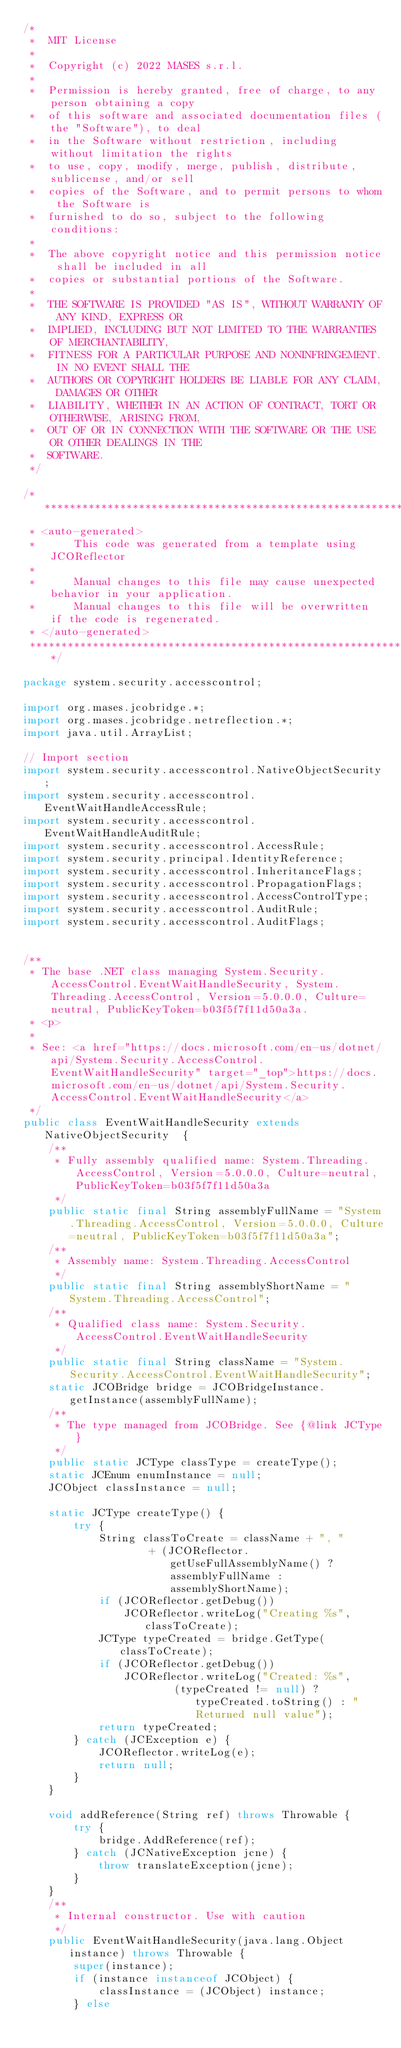<code> <loc_0><loc_0><loc_500><loc_500><_Java_>/*
 *  MIT License
 *
 *  Copyright (c) 2022 MASES s.r.l.
 *
 *  Permission is hereby granted, free of charge, to any person obtaining a copy
 *  of this software and associated documentation files (the "Software"), to deal
 *  in the Software without restriction, including without limitation the rights
 *  to use, copy, modify, merge, publish, distribute, sublicense, and/or sell
 *  copies of the Software, and to permit persons to whom the Software is
 *  furnished to do so, subject to the following conditions:
 *
 *  The above copyright notice and this permission notice shall be included in all
 *  copies or substantial portions of the Software.
 *
 *  THE SOFTWARE IS PROVIDED "AS IS", WITHOUT WARRANTY OF ANY KIND, EXPRESS OR
 *  IMPLIED, INCLUDING BUT NOT LIMITED TO THE WARRANTIES OF MERCHANTABILITY,
 *  FITNESS FOR A PARTICULAR PURPOSE AND NONINFRINGEMENT. IN NO EVENT SHALL THE
 *  AUTHORS OR COPYRIGHT HOLDERS BE LIABLE FOR ANY CLAIM, DAMAGES OR OTHER
 *  LIABILITY, WHETHER IN AN ACTION OF CONTRACT, TORT OR OTHERWISE, ARISING FROM,
 *  OUT OF OR IN CONNECTION WITH THE SOFTWARE OR THE USE OR OTHER DEALINGS IN THE
 *  SOFTWARE.
 */

/**************************************************************************************
 * <auto-generated>
 *      This code was generated from a template using JCOReflector
 * 
 *      Manual changes to this file may cause unexpected behavior in your application.
 *      Manual changes to this file will be overwritten if the code is regenerated.
 * </auto-generated>
 *************************************************************************************/

package system.security.accesscontrol;

import org.mases.jcobridge.*;
import org.mases.jcobridge.netreflection.*;
import java.util.ArrayList;

// Import section
import system.security.accesscontrol.NativeObjectSecurity;
import system.security.accesscontrol.EventWaitHandleAccessRule;
import system.security.accesscontrol.EventWaitHandleAuditRule;
import system.security.accesscontrol.AccessRule;
import system.security.principal.IdentityReference;
import system.security.accesscontrol.InheritanceFlags;
import system.security.accesscontrol.PropagationFlags;
import system.security.accesscontrol.AccessControlType;
import system.security.accesscontrol.AuditRule;
import system.security.accesscontrol.AuditFlags;


/**
 * The base .NET class managing System.Security.AccessControl.EventWaitHandleSecurity, System.Threading.AccessControl, Version=5.0.0.0, Culture=neutral, PublicKeyToken=b03f5f7f11d50a3a.
 * <p>
 * 
 * See: <a href="https://docs.microsoft.com/en-us/dotnet/api/System.Security.AccessControl.EventWaitHandleSecurity" target="_top">https://docs.microsoft.com/en-us/dotnet/api/System.Security.AccessControl.EventWaitHandleSecurity</a>
 */
public class EventWaitHandleSecurity extends NativeObjectSecurity  {
    /**
     * Fully assembly qualified name: System.Threading.AccessControl, Version=5.0.0.0, Culture=neutral, PublicKeyToken=b03f5f7f11d50a3a
     */
    public static final String assemblyFullName = "System.Threading.AccessControl, Version=5.0.0.0, Culture=neutral, PublicKeyToken=b03f5f7f11d50a3a";
    /**
     * Assembly name: System.Threading.AccessControl
     */
    public static final String assemblyShortName = "System.Threading.AccessControl";
    /**
     * Qualified class name: System.Security.AccessControl.EventWaitHandleSecurity
     */
    public static final String className = "System.Security.AccessControl.EventWaitHandleSecurity";
    static JCOBridge bridge = JCOBridgeInstance.getInstance(assemblyFullName);
    /**
     * The type managed from JCOBridge. See {@link JCType}
     */
    public static JCType classType = createType();
    static JCEnum enumInstance = null;
    JCObject classInstance = null;

    static JCType createType() {
        try {
            String classToCreate = className + ", "
                    + (JCOReflector.getUseFullAssemblyName() ? assemblyFullName : assemblyShortName);
            if (JCOReflector.getDebug())
                JCOReflector.writeLog("Creating %s", classToCreate);
            JCType typeCreated = bridge.GetType(classToCreate);
            if (JCOReflector.getDebug())
                JCOReflector.writeLog("Created: %s",
                        (typeCreated != null) ? typeCreated.toString() : "Returned null value");
            return typeCreated;
        } catch (JCException e) {
            JCOReflector.writeLog(e);
            return null;
        }
    }

    void addReference(String ref) throws Throwable {
        try {
            bridge.AddReference(ref);
        } catch (JCNativeException jcne) {
            throw translateException(jcne);
        }
    }
    /**
     * Internal constructor. Use with caution 
     */
    public EventWaitHandleSecurity(java.lang.Object instance) throws Throwable {
        super(instance);
        if (instance instanceof JCObject) {
            classInstance = (JCObject) instance;
        } else</code> 